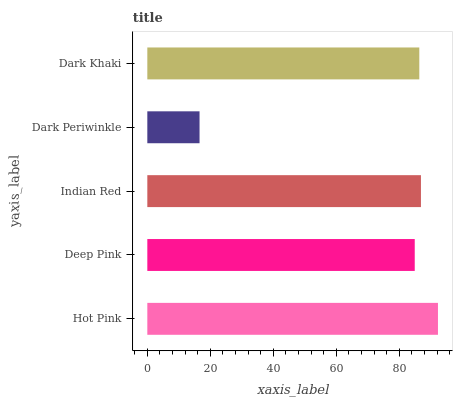Is Dark Periwinkle the minimum?
Answer yes or no. Yes. Is Hot Pink the maximum?
Answer yes or no. Yes. Is Deep Pink the minimum?
Answer yes or no. No. Is Deep Pink the maximum?
Answer yes or no. No. Is Hot Pink greater than Deep Pink?
Answer yes or no. Yes. Is Deep Pink less than Hot Pink?
Answer yes or no. Yes. Is Deep Pink greater than Hot Pink?
Answer yes or no. No. Is Hot Pink less than Deep Pink?
Answer yes or no. No. Is Dark Khaki the high median?
Answer yes or no. Yes. Is Dark Khaki the low median?
Answer yes or no. Yes. Is Deep Pink the high median?
Answer yes or no. No. Is Hot Pink the low median?
Answer yes or no. No. 